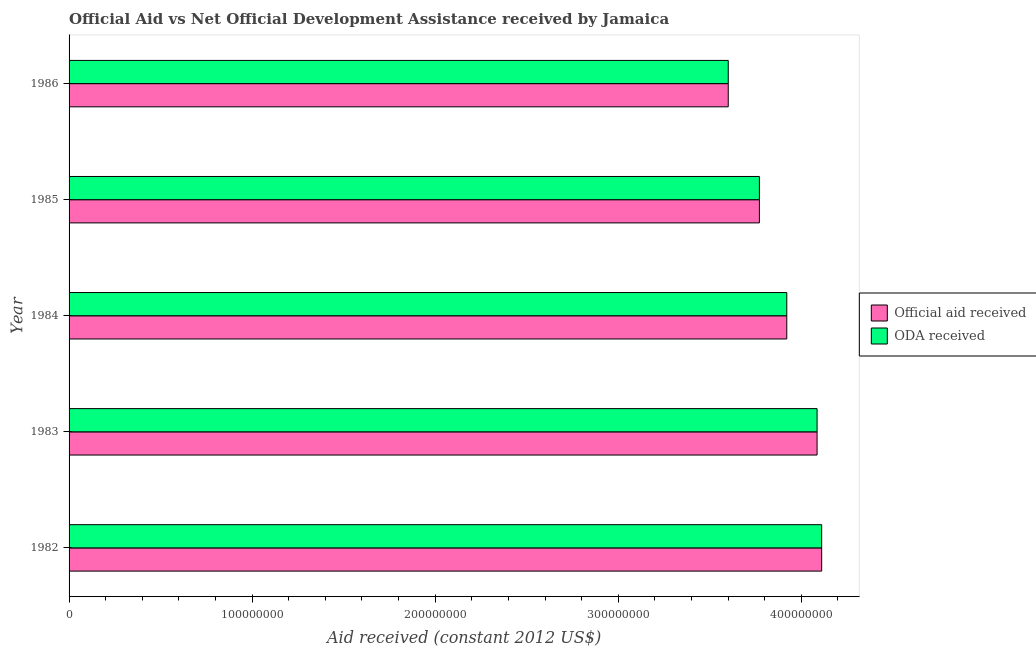Are the number of bars per tick equal to the number of legend labels?
Ensure brevity in your answer.  Yes. How many bars are there on the 5th tick from the top?
Give a very brief answer. 2. What is the label of the 3rd group of bars from the top?
Provide a short and direct response. 1984. In how many cases, is the number of bars for a given year not equal to the number of legend labels?
Your answer should be very brief. 0. What is the oda received in 1983?
Offer a very short reply. 4.09e+08. Across all years, what is the maximum official aid received?
Your answer should be very brief. 4.11e+08. Across all years, what is the minimum oda received?
Offer a terse response. 3.60e+08. In which year was the official aid received maximum?
Keep it short and to the point. 1982. What is the total oda received in the graph?
Your response must be concise. 1.95e+09. What is the difference between the official aid received in 1982 and that in 1983?
Provide a short and direct response. 2.51e+06. What is the difference between the official aid received in 1985 and the oda received in 1982?
Your answer should be compact. -3.40e+07. What is the average official aid received per year?
Your answer should be very brief. 3.90e+08. What is the ratio of the official aid received in 1982 to that in 1985?
Give a very brief answer. 1.09. Is the difference between the official aid received in 1983 and 1985 greater than the difference between the oda received in 1983 and 1985?
Your answer should be very brief. No. What is the difference between the highest and the second highest oda received?
Keep it short and to the point. 2.51e+06. What is the difference between the highest and the lowest oda received?
Offer a very short reply. 5.10e+07. Is the sum of the official aid received in 1983 and 1986 greater than the maximum oda received across all years?
Keep it short and to the point. Yes. What does the 1st bar from the top in 1982 represents?
Provide a succinct answer. ODA received. What does the 2nd bar from the bottom in 1982 represents?
Give a very brief answer. ODA received. How many bars are there?
Provide a succinct answer. 10. Are all the bars in the graph horizontal?
Offer a terse response. Yes. What is the difference between two consecutive major ticks on the X-axis?
Offer a terse response. 1.00e+08. Are the values on the major ticks of X-axis written in scientific E-notation?
Keep it short and to the point. No. Does the graph contain any zero values?
Your response must be concise. No. What is the title of the graph?
Offer a very short reply. Official Aid vs Net Official Development Assistance received by Jamaica . Does "Savings" appear as one of the legend labels in the graph?
Give a very brief answer. No. What is the label or title of the X-axis?
Give a very brief answer. Aid received (constant 2012 US$). What is the label or title of the Y-axis?
Your answer should be compact. Year. What is the Aid received (constant 2012 US$) in Official aid received in 1982?
Provide a succinct answer. 4.11e+08. What is the Aid received (constant 2012 US$) of ODA received in 1982?
Your response must be concise. 4.11e+08. What is the Aid received (constant 2012 US$) of Official aid received in 1983?
Offer a very short reply. 4.09e+08. What is the Aid received (constant 2012 US$) in ODA received in 1983?
Your answer should be compact. 4.09e+08. What is the Aid received (constant 2012 US$) of Official aid received in 1984?
Your answer should be very brief. 3.92e+08. What is the Aid received (constant 2012 US$) in ODA received in 1984?
Your answer should be very brief. 3.92e+08. What is the Aid received (constant 2012 US$) of Official aid received in 1985?
Keep it short and to the point. 3.77e+08. What is the Aid received (constant 2012 US$) of ODA received in 1985?
Your answer should be compact. 3.77e+08. What is the Aid received (constant 2012 US$) of Official aid received in 1986?
Give a very brief answer. 3.60e+08. What is the Aid received (constant 2012 US$) in ODA received in 1986?
Ensure brevity in your answer.  3.60e+08. Across all years, what is the maximum Aid received (constant 2012 US$) of Official aid received?
Offer a terse response. 4.11e+08. Across all years, what is the maximum Aid received (constant 2012 US$) in ODA received?
Provide a short and direct response. 4.11e+08. Across all years, what is the minimum Aid received (constant 2012 US$) of Official aid received?
Provide a short and direct response. 3.60e+08. Across all years, what is the minimum Aid received (constant 2012 US$) in ODA received?
Provide a succinct answer. 3.60e+08. What is the total Aid received (constant 2012 US$) of Official aid received in the graph?
Keep it short and to the point. 1.95e+09. What is the total Aid received (constant 2012 US$) in ODA received in the graph?
Offer a terse response. 1.95e+09. What is the difference between the Aid received (constant 2012 US$) in Official aid received in 1982 and that in 1983?
Provide a succinct answer. 2.51e+06. What is the difference between the Aid received (constant 2012 US$) of ODA received in 1982 and that in 1983?
Your response must be concise. 2.51e+06. What is the difference between the Aid received (constant 2012 US$) of Official aid received in 1982 and that in 1984?
Provide a succinct answer. 1.91e+07. What is the difference between the Aid received (constant 2012 US$) in ODA received in 1982 and that in 1984?
Offer a terse response. 1.91e+07. What is the difference between the Aid received (constant 2012 US$) in Official aid received in 1982 and that in 1985?
Your response must be concise. 3.40e+07. What is the difference between the Aid received (constant 2012 US$) in ODA received in 1982 and that in 1985?
Your answer should be very brief. 3.40e+07. What is the difference between the Aid received (constant 2012 US$) in Official aid received in 1982 and that in 1986?
Your answer should be very brief. 5.10e+07. What is the difference between the Aid received (constant 2012 US$) in ODA received in 1982 and that in 1986?
Provide a short and direct response. 5.10e+07. What is the difference between the Aid received (constant 2012 US$) of Official aid received in 1983 and that in 1984?
Offer a terse response. 1.66e+07. What is the difference between the Aid received (constant 2012 US$) of ODA received in 1983 and that in 1984?
Provide a succinct answer. 1.66e+07. What is the difference between the Aid received (constant 2012 US$) in Official aid received in 1983 and that in 1985?
Provide a succinct answer. 3.15e+07. What is the difference between the Aid received (constant 2012 US$) of ODA received in 1983 and that in 1985?
Provide a succinct answer. 3.15e+07. What is the difference between the Aid received (constant 2012 US$) of Official aid received in 1983 and that in 1986?
Provide a succinct answer. 4.85e+07. What is the difference between the Aid received (constant 2012 US$) in ODA received in 1983 and that in 1986?
Your answer should be compact. 4.85e+07. What is the difference between the Aid received (constant 2012 US$) in Official aid received in 1984 and that in 1985?
Offer a very short reply. 1.50e+07. What is the difference between the Aid received (constant 2012 US$) of ODA received in 1984 and that in 1985?
Provide a succinct answer. 1.50e+07. What is the difference between the Aid received (constant 2012 US$) of Official aid received in 1984 and that in 1986?
Keep it short and to the point. 3.20e+07. What is the difference between the Aid received (constant 2012 US$) of ODA received in 1984 and that in 1986?
Make the answer very short. 3.20e+07. What is the difference between the Aid received (constant 2012 US$) of Official aid received in 1985 and that in 1986?
Ensure brevity in your answer.  1.70e+07. What is the difference between the Aid received (constant 2012 US$) in ODA received in 1985 and that in 1986?
Provide a short and direct response. 1.70e+07. What is the difference between the Aid received (constant 2012 US$) in Official aid received in 1982 and the Aid received (constant 2012 US$) in ODA received in 1983?
Keep it short and to the point. 2.51e+06. What is the difference between the Aid received (constant 2012 US$) in Official aid received in 1982 and the Aid received (constant 2012 US$) in ODA received in 1984?
Offer a terse response. 1.91e+07. What is the difference between the Aid received (constant 2012 US$) of Official aid received in 1982 and the Aid received (constant 2012 US$) of ODA received in 1985?
Your answer should be very brief. 3.40e+07. What is the difference between the Aid received (constant 2012 US$) of Official aid received in 1982 and the Aid received (constant 2012 US$) of ODA received in 1986?
Make the answer very short. 5.10e+07. What is the difference between the Aid received (constant 2012 US$) in Official aid received in 1983 and the Aid received (constant 2012 US$) in ODA received in 1984?
Your answer should be very brief. 1.66e+07. What is the difference between the Aid received (constant 2012 US$) of Official aid received in 1983 and the Aid received (constant 2012 US$) of ODA received in 1985?
Your response must be concise. 3.15e+07. What is the difference between the Aid received (constant 2012 US$) in Official aid received in 1983 and the Aid received (constant 2012 US$) in ODA received in 1986?
Provide a short and direct response. 4.85e+07. What is the difference between the Aid received (constant 2012 US$) of Official aid received in 1984 and the Aid received (constant 2012 US$) of ODA received in 1985?
Ensure brevity in your answer.  1.50e+07. What is the difference between the Aid received (constant 2012 US$) of Official aid received in 1984 and the Aid received (constant 2012 US$) of ODA received in 1986?
Make the answer very short. 3.20e+07. What is the difference between the Aid received (constant 2012 US$) of Official aid received in 1985 and the Aid received (constant 2012 US$) of ODA received in 1986?
Ensure brevity in your answer.  1.70e+07. What is the average Aid received (constant 2012 US$) of Official aid received per year?
Offer a very short reply. 3.90e+08. What is the average Aid received (constant 2012 US$) in ODA received per year?
Offer a terse response. 3.90e+08. In the year 1983, what is the difference between the Aid received (constant 2012 US$) in Official aid received and Aid received (constant 2012 US$) in ODA received?
Your answer should be very brief. 0. In the year 1986, what is the difference between the Aid received (constant 2012 US$) of Official aid received and Aid received (constant 2012 US$) of ODA received?
Provide a succinct answer. 0. What is the ratio of the Aid received (constant 2012 US$) of Official aid received in 1982 to that in 1983?
Offer a very short reply. 1.01. What is the ratio of the Aid received (constant 2012 US$) of Official aid received in 1982 to that in 1984?
Ensure brevity in your answer.  1.05. What is the ratio of the Aid received (constant 2012 US$) in ODA received in 1982 to that in 1984?
Ensure brevity in your answer.  1.05. What is the ratio of the Aid received (constant 2012 US$) in Official aid received in 1982 to that in 1985?
Provide a succinct answer. 1.09. What is the ratio of the Aid received (constant 2012 US$) in ODA received in 1982 to that in 1985?
Make the answer very short. 1.09. What is the ratio of the Aid received (constant 2012 US$) of Official aid received in 1982 to that in 1986?
Offer a terse response. 1.14. What is the ratio of the Aid received (constant 2012 US$) of ODA received in 1982 to that in 1986?
Make the answer very short. 1.14. What is the ratio of the Aid received (constant 2012 US$) of Official aid received in 1983 to that in 1984?
Give a very brief answer. 1.04. What is the ratio of the Aid received (constant 2012 US$) in ODA received in 1983 to that in 1984?
Give a very brief answer. 1.04. What is the ratio of the Aid received (constant 2012 US$) in Official aid received in 1983 to that in 1985?
Give a very brief answer. 1.08. What is the ratio of the Aid received (constant 2012 US$) in ODA received in 1983 to that in 1985?
Provide a short and direct response. 1.08. What is the ratio of the Aid received (constant 2012 US$) in Official aid received in 1983 to that in 1986?
Offer a very short reply. 1.13. What is the ratio of the Aid received (constant 2012 US$) of ODA received in 1983 to that in 1986?
Give a very brief answer. 1.13. What is the ratio of the Aid received (constant 2012 US$) in Official aid received in 1984 to that in 1985?
Your answer should be compact. 1.04. What is the ratio of the Aid received (constant 2012 US$) in ODA received in 1984 to that in 1985?
Offer a terse response. 1.04. What is the ratio of the Aid received (constant 2012 US$) in Official aid received in 1984 to that in 1986?
Your response must be concise. 1.09. What is the ratio of the Aid received (constant 2012 US$) of ODA received in 1984 to that in 1986?
Your answer should be compact. 1.09. What is the ratio of the Aid received (constant 2012 US$) in Official aid received in 1985 to that in 1986?
Make the answer very short. 1.05. What is the ratio of the Aid received (constant 2012 US$) in ODA received in 1985 to that in 1986?
Provide a short and direct response. 1.05. What is the difference between the highest and the second highest Aid received (constant 2012 US$) of Official aid received?
Make the answer very short. 2.51e+06. What is the difference between the highest and the second highest Aid received (constant 2012 US$) of ODA received?
Your answer should be compact. 2.51e+06. What is the difference between the highest and the lowest Aid received (constant 2012 US$) in Official aid received?
Make the answer very short. 5.10e+07. What is the difference between the highest and the lowest Aid received (constant 2012 US$) in ODA received?
Give a very brief answer. 5.10e+07. 